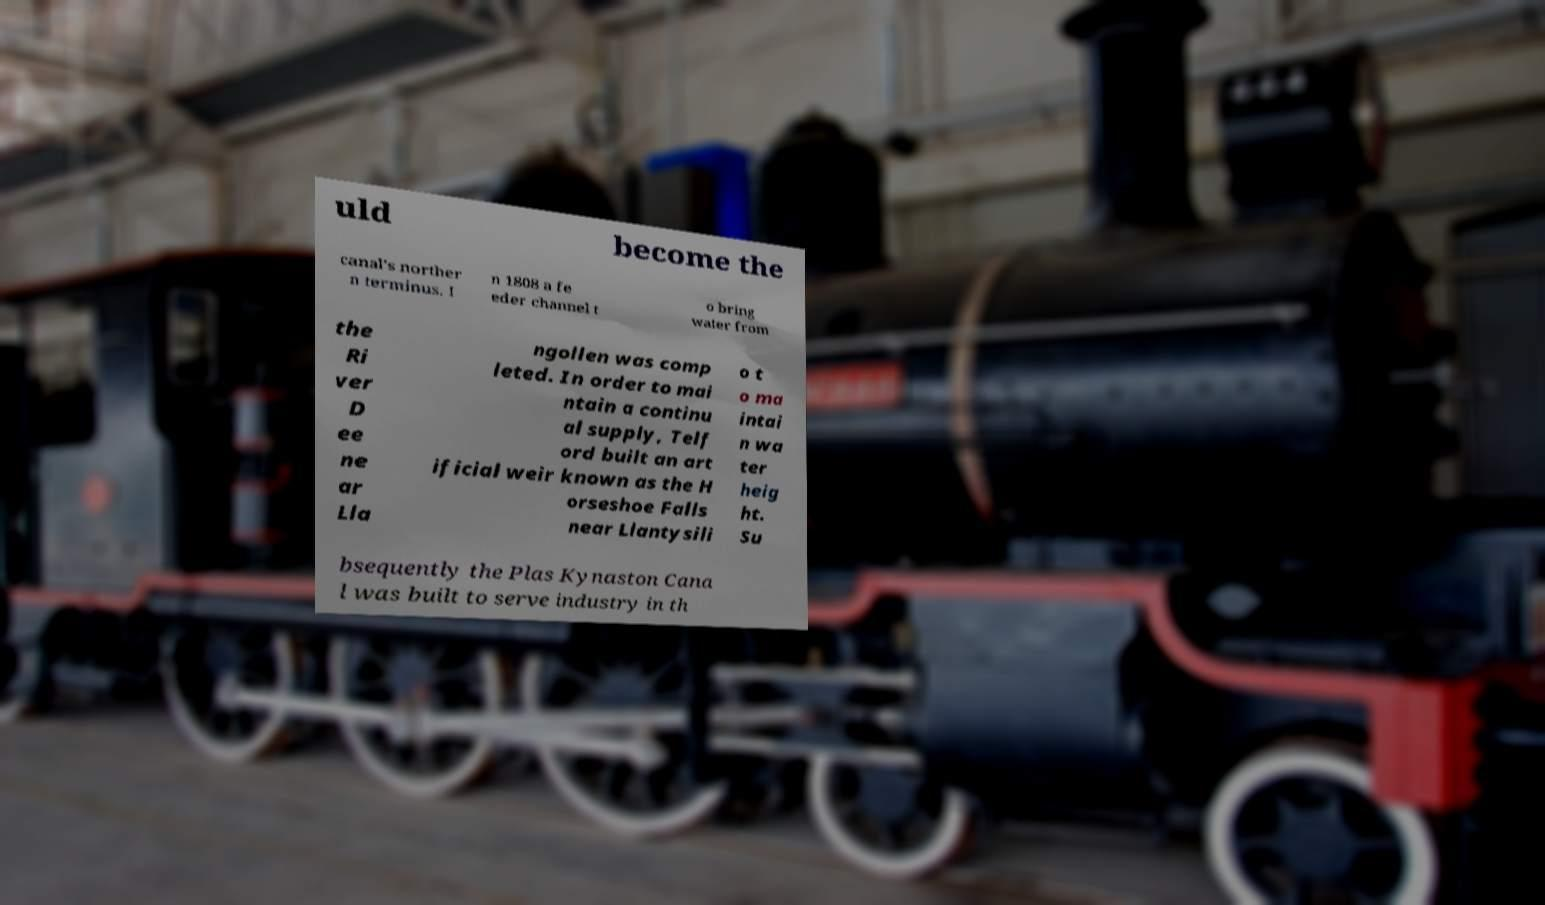Please identify and transcribe the text found in this image. uld become the canal's norther n terminus. I n 1808 a fe eder channel t o bring water from the Ri ver D ee ne ar Lla ngollen was comp leted. In order to mai ntain a continu al supply, Telf ord built an art ificial weir known as the H orseshoe Falls near Llantysili o t o ma intai n wa ter heig ht. Su bsequently the Plas Kynaston Cana l was built to serve industry in th 